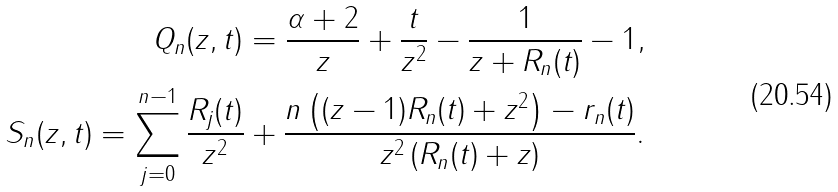<formula> <loc_0><loc_0><loc_500><loc_500>Q _ { n } ( z , t ) = \frac { \alpha + 2 } { z } + \frac { t } { z ^ { 2 } } - \frac { 1 } { z + R _ { n } ( t ) } - 1 , \\ S _ { n } ( z , t ) = \sum _ { j = 0 } ^ { n - 1 } \frac { R _ { j } ( t ) } { z ^ { 2 } } + \frac { n \left ( ( z - 1 ) R _ { n } ( t ) + z ^ { 2 } \right ) - r _ { n } ( t ) } { z ^ { 2 } \left ( R _ { n } ( t ) + z \right ) } .</formula> 